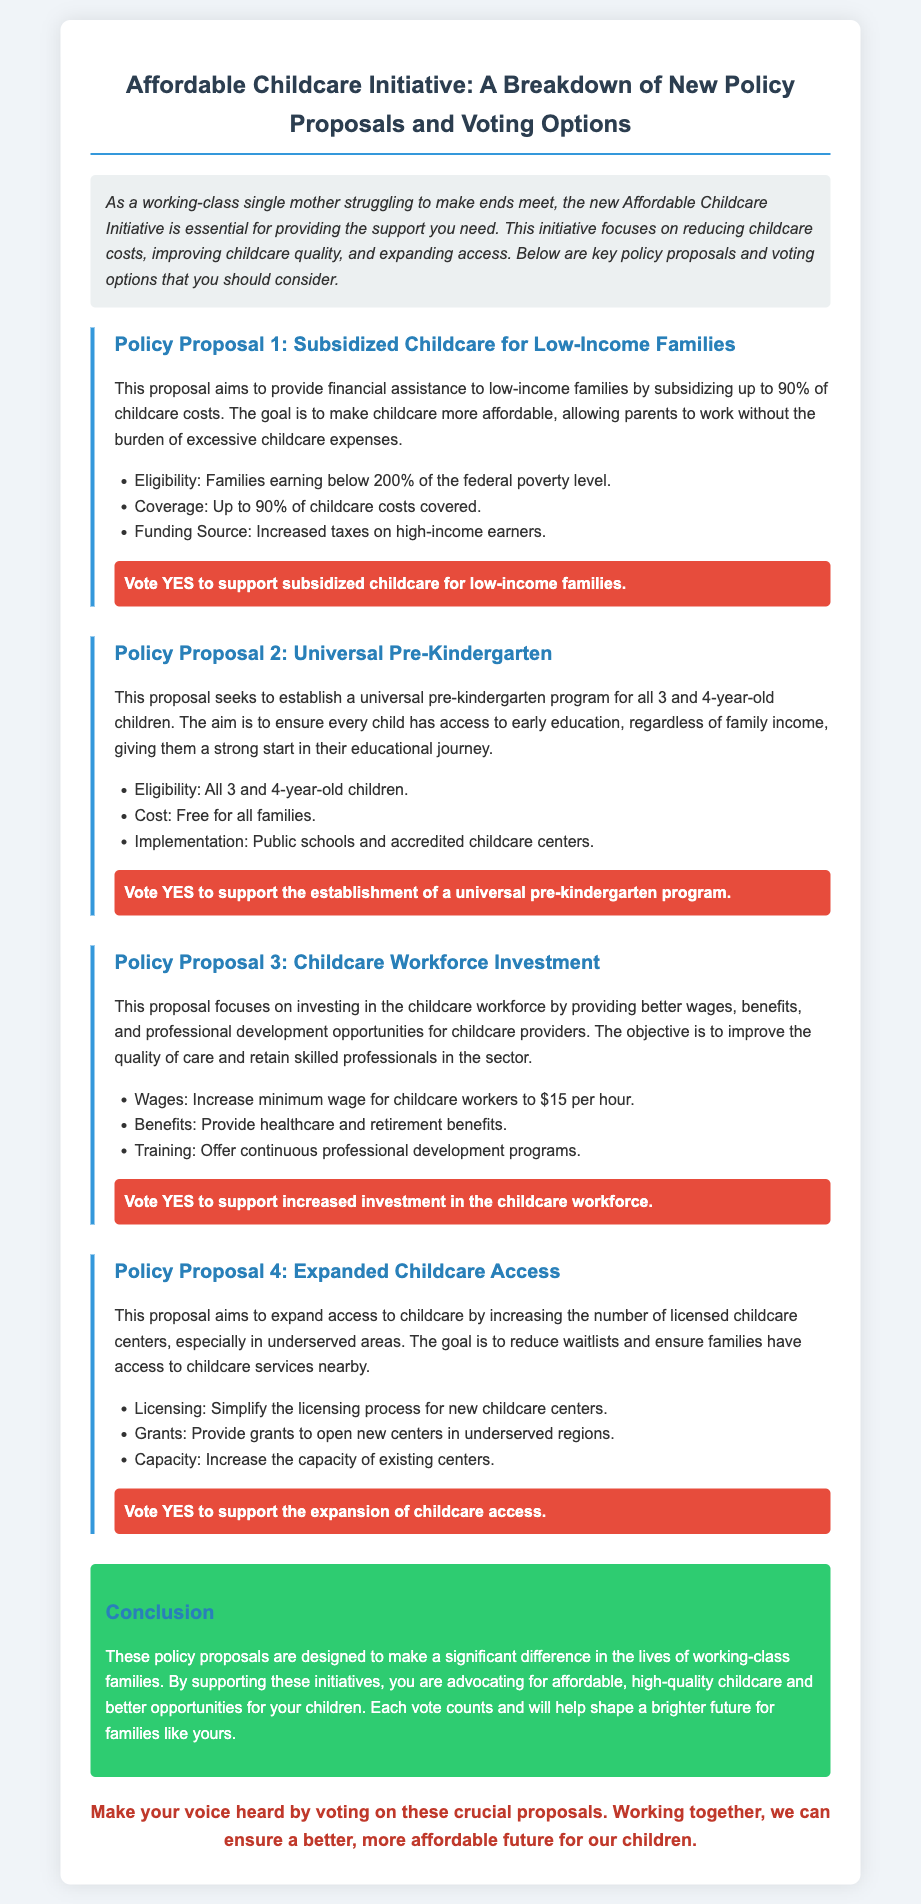What is the maximum subsidy percentage for childcare costs? The document states that up to 90% of childcare costs can be subsidized for low-income families.
Answer: 90% Who is eligible for the subsidized childcare proposal? The eligibility criteria mention families earning below 200% of the federal poverty level.
Answer: Families earning below 200% of the federal poverty level What age group does the universal pre-kindergarten program cover? The proposal specifies that all 3 and 4-year-old children are eligible for the program.
Answer: 3 and 4-year-old children What is the proposed new minimum wage for childcare workers? The document indicates that the minimum wage for childcare workers is proposed to be increased to $15 per hour.
Answer: $15 What is one of the goals of the Expanded Childcare Access proposal? The document mentions that a goal is to reduce waitlists for childcare services.
Answer: Reduce waitlists What type of benefits will childcare workers receive under the workforce investment proposal? It is stated that healthcare and retirement benefits will be provided to childcare workers.
Answer: Healthcare and retirement benefits What action should you take to support subsidized childcare? The document prompts readers to vote YES to support the proposal for subsidized childcare for low-income families.
Answer: Vote YES How does the initiative aim to fund the subsidy for low-income families? The proposal indicates that funding will come from increased taxes on high-income earners.
Answer: Increased taxes on high-income earners What is provided to assist the establishment of new childcare centers in underserved areas? The document outlines that grants will be provided to open new centers in underserved regions.
Answer: Grants 